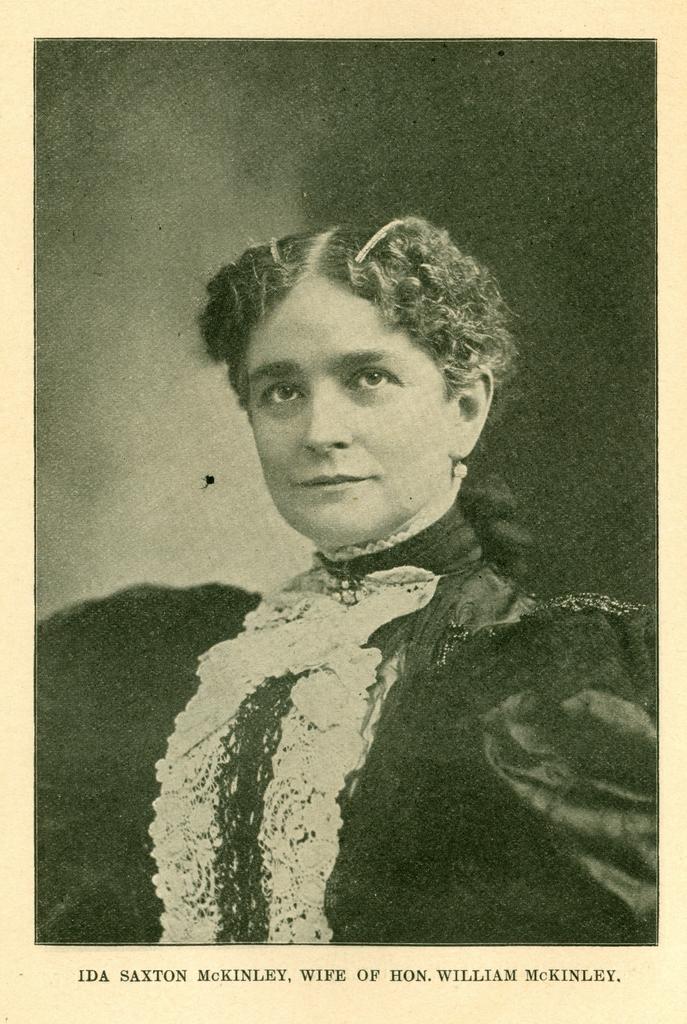How would you summarize this image in a sentence or two? In this picture we can see an object which seems to be a photograph and we can see the picture of a person. In the background we can see an object which seems to be the smoke. At the bottom we can see the text on the image. 